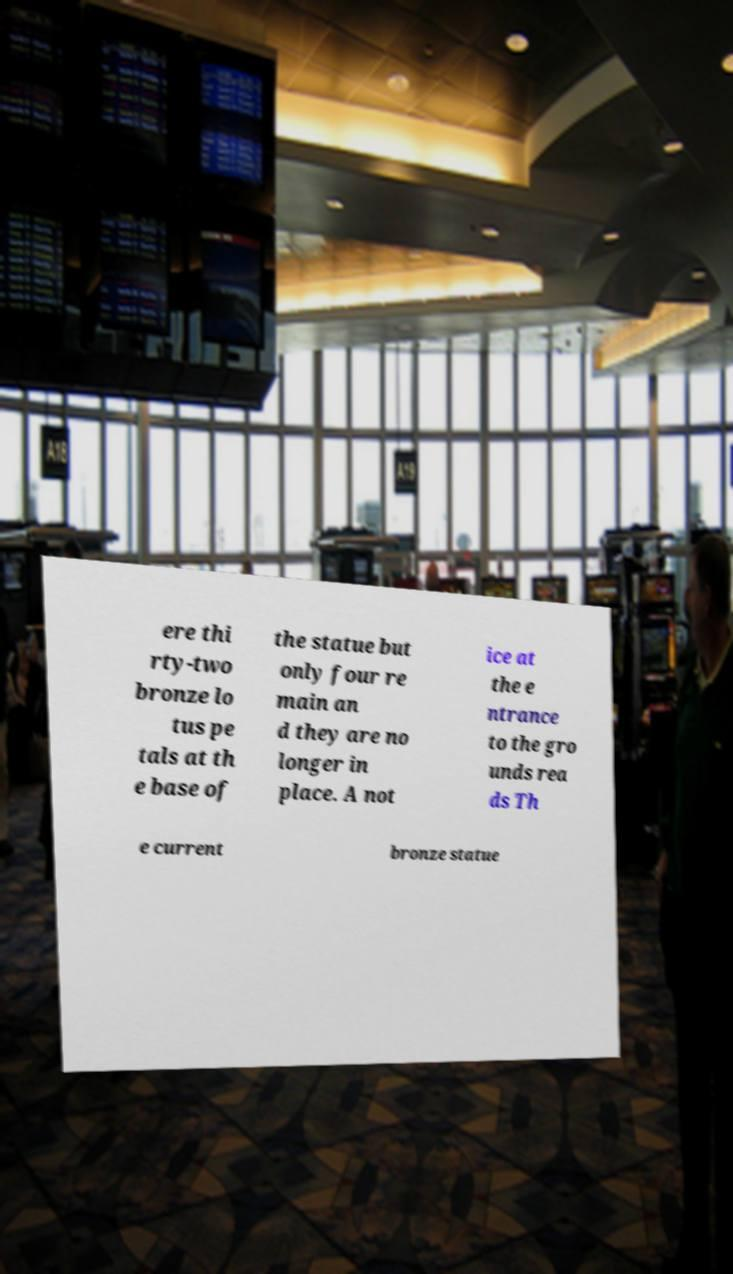Please read and relay the text visible in this image. What does it say? ere thi rty-two bronze lo tus pe tals at th e base of the statue but only four re main an d they are no longer in place. A not ice at the e ntrance to the gro unds rea ds Th e current bronze statue 